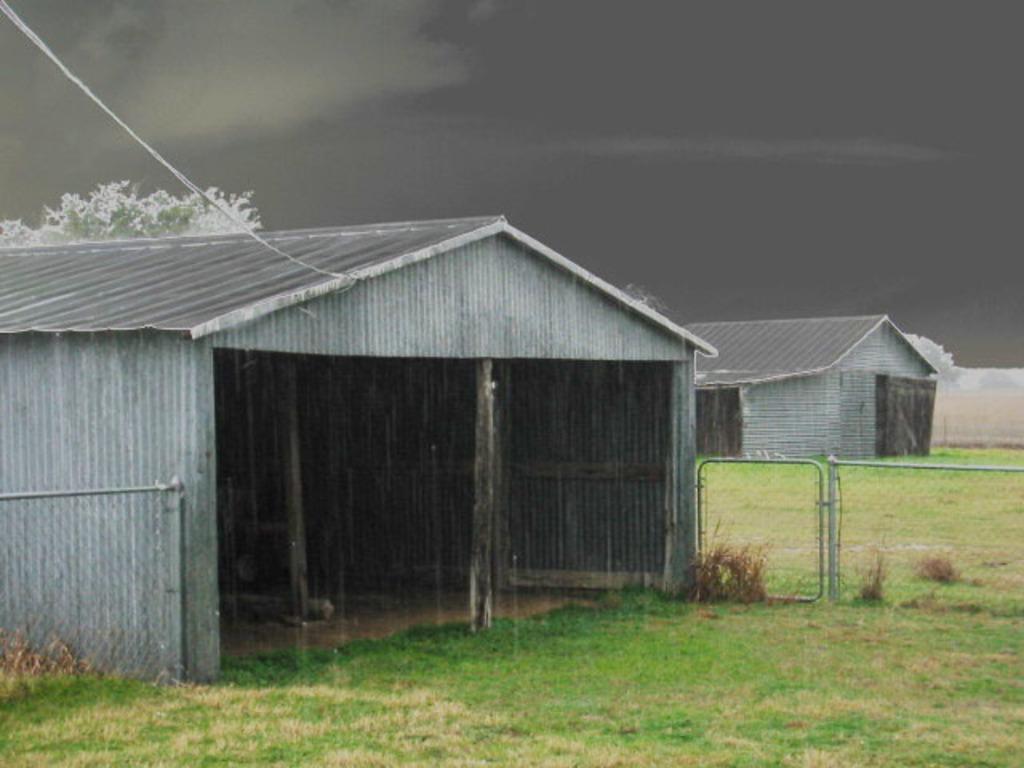Describe this image in one or two sentences. In this image there are two sheds on a land and those sheds are separated with fencing, in the background there is a cloudy sky. 